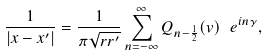Convert formula to latex. <formula><loc_0><loc_0><loc_500><loc_500>\frac { 1 } { | x - x ^ { \prime } | } = \frac { 1 } { \pi \sqrt { r r ^ { \prime } } } \sum _ { n = - \infty } ^ { \infty } Q _ { n - \frac { 1 } { 2 } } ( v ) \ e ^ { i n \gamma } ,</formula> 